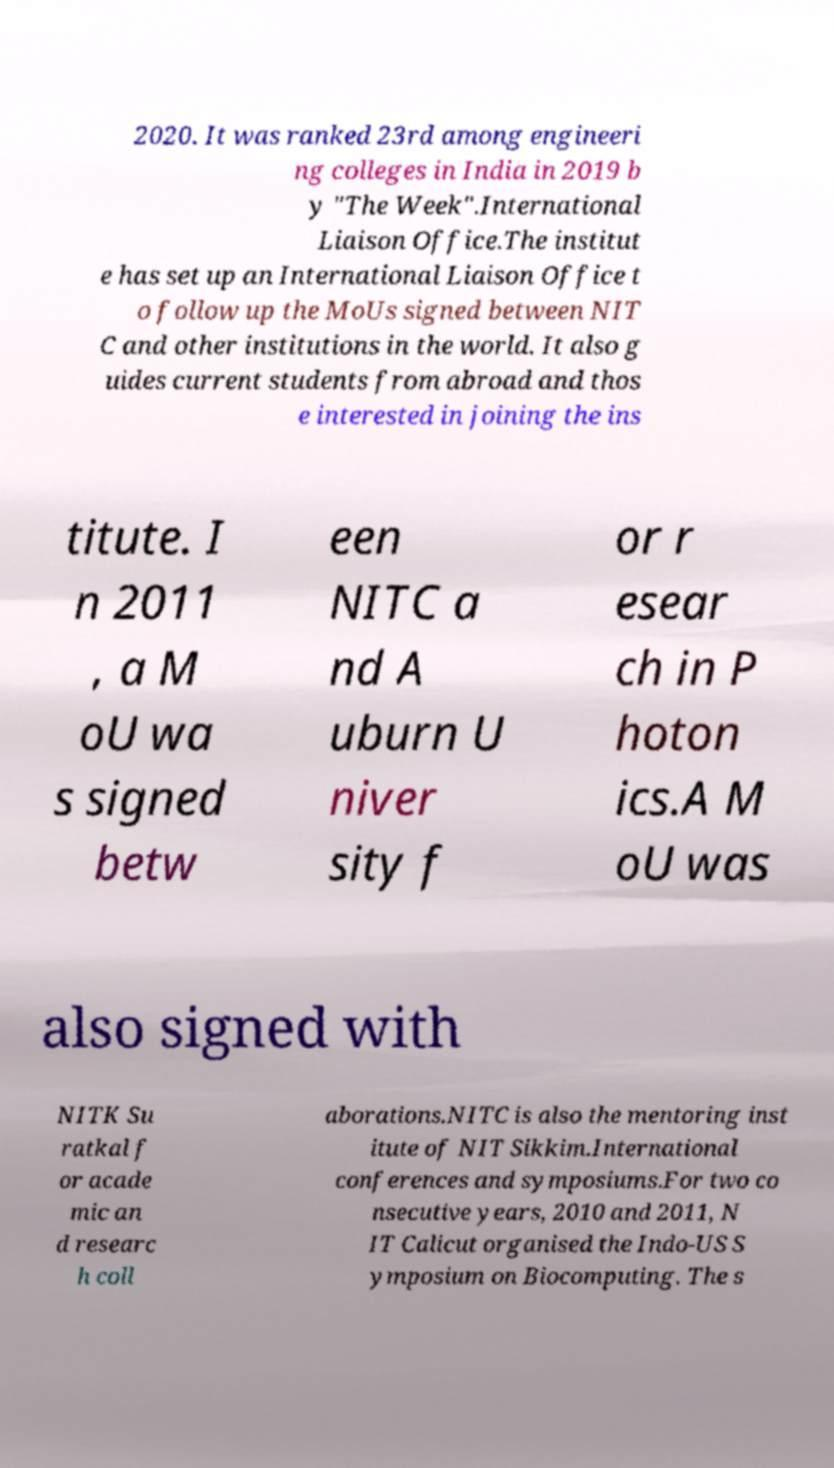Please read and relay the text visible in this image. What does it say? 2020. It was ranked 23rd among engineeri ng colleges in India in 2019 b y "The Week".International Liaison Office.The institut e has set up an International Liaison Office t o follow up the MoUs signed between NIT C and other institutions in the world. It also g uides current students from abroad and thos e interested in joining the ins titute. I n 2011 , a M oU wa s signed betw een NITC a nd A uburn U niver sity f or r esear ch in P hoton ics.A M oU was also signed with NITK Su ratkal f or acade mic an d researc h coll aborations.NITC is also the mentoring inst itute of NIT Sikkim.International conferences and symposiums.For two co nsecutive years, 2010 and 2011, N IT Calicut organised the Indo-US S ymposium on Biocomputing. The s 